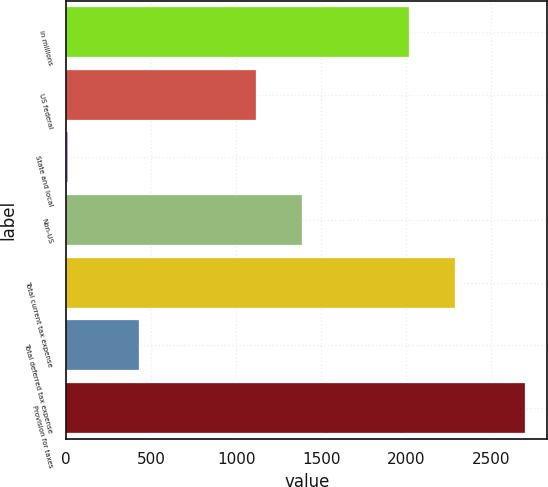<chart> <loc_0><loc_0><loc_500><loc_500><bar_chart><fcel>in millions<fcel>US federal<fcel>State and local<fcel>Non-US<fcel>Total current tax expense<fcel>Total deferred tax expense<fcel>Provision for taxes<nl><fcel>2015<fcel>1116<fcel>12<fcel>1384.3<fcel>2283.3<fcel>425<fcel>2695<nl></chart> 